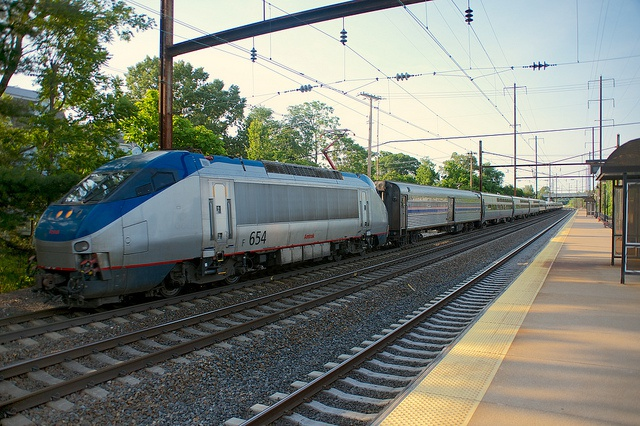Describe the objects in this image and their specific colors. I can see a train in gray, black, and darkgray tones in this image. 